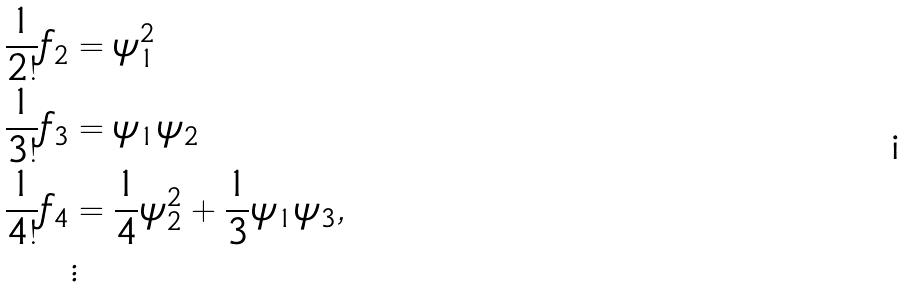Convert formula to latex. <formula><loc_0><loc_0><loc_500><loc_500>\frac { 1 } { 2 ! } f _ { 2 } & = \psi _ { 1 } ^ { 2 } \\ \frac { 1 } { 3 ! } f _ { 3 } & = \psi _ { 1 } \psi _ { 2 } \\ \frac { 1 } { 4 ! } f _ { 4 } & = \frac { 1 } { 4 } \psi ^ { 2 } _ { 2 } + \frac { 1 } { 3 } \psi _ { 1 } \psi _ { 3 } , \\ & \vdots</formula> 